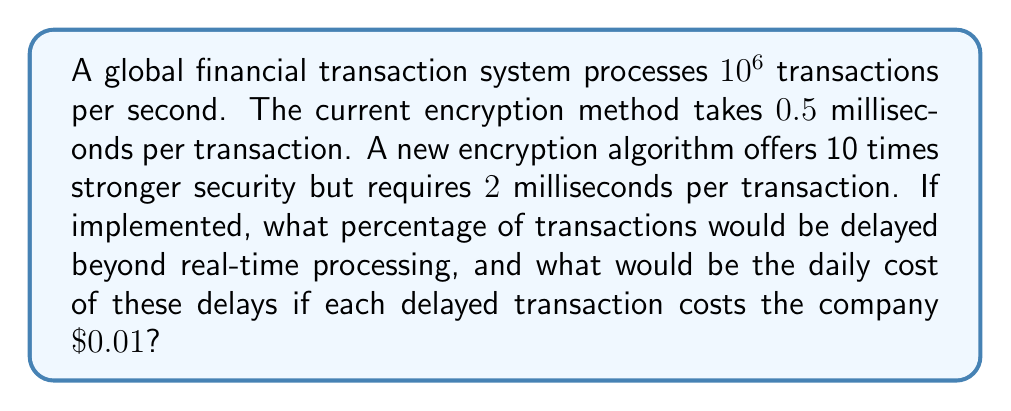Teach me how to tackle this problem. 1) Current processing capacity:
   $$\frac{1000 \text{ ms}}{0.5 \text{ ms/transaction}} = 2000 \text{ transactions/second}$$

2) New algorithm capacity:
   $$\frac{1000 \text{ ms}}{2 \text{ ms/transaction}} = 500 \text{ transactions/second}$$

3) Percentage of delayed transactions:
   $$\frac{10^6 - 500}{10^6} \times 100\% = 99.95\%$$

4) Number of delayed transactions per day:
   $$99.95\% \times 10^6 \times 60 \times 60 \times 24 = 8.63568 \times 10^{10}$$

5) Daily cost of delays:
   $$8.63568 \times 10^{10} \times $0.01 = $863,568,000$$
Answer: 99.95% delayed; $863,568,000 daily cost 